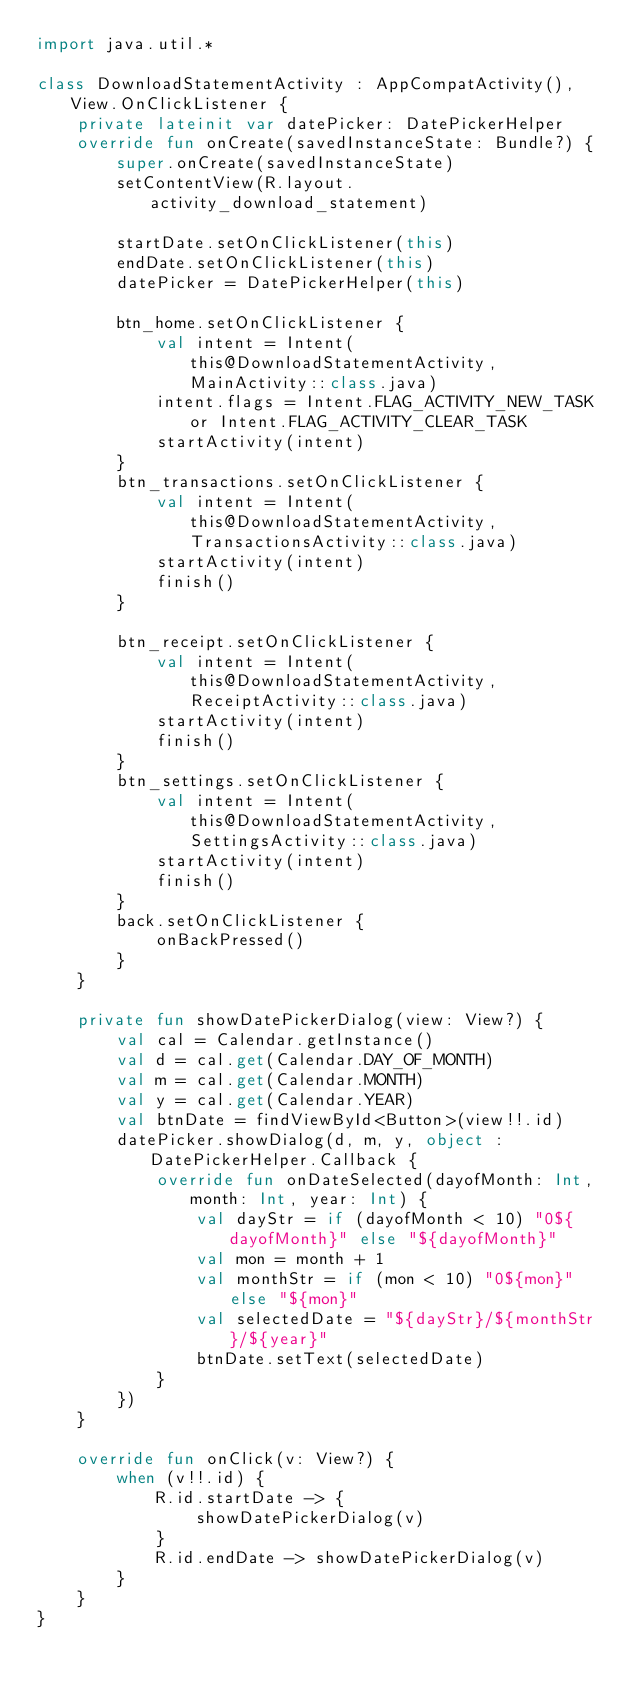Convert code to text. <code><loc_0><loc_0><loc_500><loc_500><_Kotlin_>import java.util.*

class DownloadStatementActivity : AppCompatActivity(), View.OnClickListener {
    private lateinit var datePicker: DatePickerHelper
    override fun onCreate(savedInstanceState: Bundle?) {
        super.onCreate(savedInstanceState)
        setContentView(R.layout.activity_download_statement)

        startDate.setOnClickListener(this)
        endDate.setOnClickListener(this)
        datePicker = DatePickerHelper(this)

        btn_home.setOnClickListener {
            val intent = Intent(this@DownloadStatementActivity, MainActivity::class.java)
            intent.flags = Intent.FLAG_ACTIVITY_NEW_TASK or Intent.FLAG_ACTIVITY_CLEAR_TASK
            startActivity(intent)
        }
        btn_transactions.setOnClickListener {
            val intent = Intent(this@DownloadStatementActivity, TransactionsActivity::class.java)
            startActivity(intent)
            finish()
        }

        btn_receipt.setOnClickListener {
            val intent = Intent(this@DownloadStatementActivity, ReceiptActivity::class.java)
            startActivity(intent)
            finish()
        }
        btn_settings.setOnClickListener {
            val intent = Intent(this@DownloadStatementActivity, SettingsActivity::class.java)
            startActivity(intent)
            finish()
        }
        back.setOnClickListener {
            onBackPressed()
        }
    }

    private fun showDatePickerDialog(view: View?) {
        val cal = Calendar.getInstance()
        val d = cal.get(Calendar.DAY_OF_MONTH)
        val m = cal.get(Calendar.MONTH)
        val y = cal.get(Calendar.YEAR)
        val btnDate = findViewById<Button>(view!!.id)
        datePicker.showDialog(d, m, y, object : DatePickerHelper.Callback {
            override fun onDateSelected(dayofMonth: Int, month: Int, year: Int) {
                val dayStr = if (dayofMonth < 10) "0${dayofMonth}" else "${dayofMonth}"
                val mon = month + 1
                val monthStr = if (mon < 10) "0${mon}" else "${mon}"
                val selectedDate = "${dayStr}/${monthStr}/${year}"
                btnDate.setText(selectedDate)
            }
        })
    }

    override fun onClick(v: View?) {
        when (v!!.id) {
            R.id.startDate -> {
                showDatePickerDialog(v)
            }
            R.id.endDate -> showDatePickerDialog(v)
        }
    }
}

</code> 